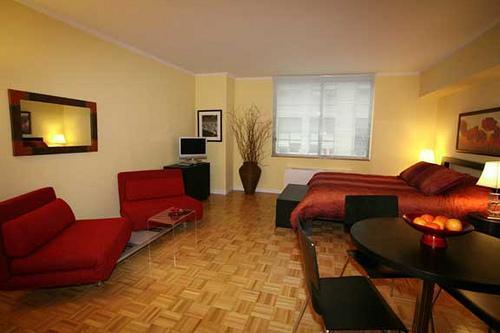How many vases appear in the room?
Give a very brief answer. 1. How many chairs are in the picture?
Give a very brief answer. 2. How many couches are visible?
Give a very brief answer. 2. How many beds are there?
Give a very brief answer. 1. 